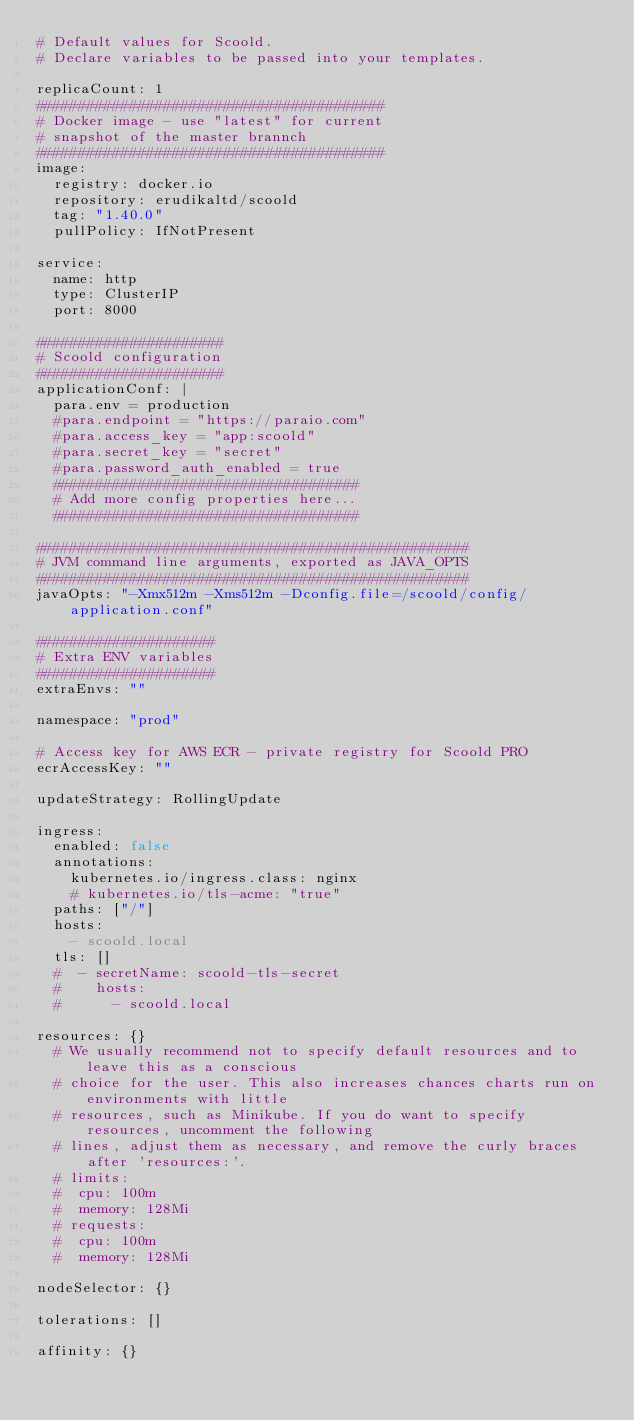<code> <loc_0><loc_0><loc_500><loc_500><_YAML_># Default values for Scoold.
# Declare variables to be passed into your templates.

replicaCount: 1
#########################################
# Docker image - use "latest" for current 
# snapshot of the master brannch
#########################################
image:
  registry: docker.io
  repository: erudikaltd/scoold
  tag: "1.40.0"
  pullPolicy: IfNotPresent

service:
  name: http
  type: ClusterIP
  port: 8000

######################
# Scoold configuration
######################
applicationConf: |
  para.env = production
  #para.endpoint = "https://paraio.com"
  #para.access_key = "app:scoold"
  #para.secret_key = "secret"
  #para.password_auth_enabled = true
  ####################################
  # Add more config properties here...
  ####################################

###################################################
# JVM command line arguments, exported as JAVA_OPTS
###################################################
javaOpts: "-Xmx512m -Xms512m -Dconfig.file=/scoold/config/application.conf"

#####################
# Extra ENV variables
#####################
extraEnvs: ""

namespace: "prod"

# Access key for AWS ECR - private registry for Scoold PRO
ecrAccessKey: ""

updateStrategy: RollingUpdate

ingress:
  enabled: false
  annotations:
    kubernetes.io/ingress.class: nginx
    # kubernetes.io/tls-acme: "true"
  paths: ["/"]
  hosts:
    - scoold.local
  tls: []
  #  - secretName: scoold-tls-secret
  #    hosts:
  #      - scoold.local

resources: {}
  # We usually recommend not to specify default resources and to leave this as a conscious
  # choice for the user. This also increases chances charts run on environments with little
  # resources, such as Minikube. If you do want to specify resources, uncomment the following
  # lines, adjust them as necessary, and remove the curly braces after 'resources:'.
  # limits:
  #  cpu: 100m
  #  memory: 128Mi
  # requests:
  #  cpu: 100m
  #  memory: 128Mi

nodeSelector: {}

tolerations: []

affinity: {}
</code> 